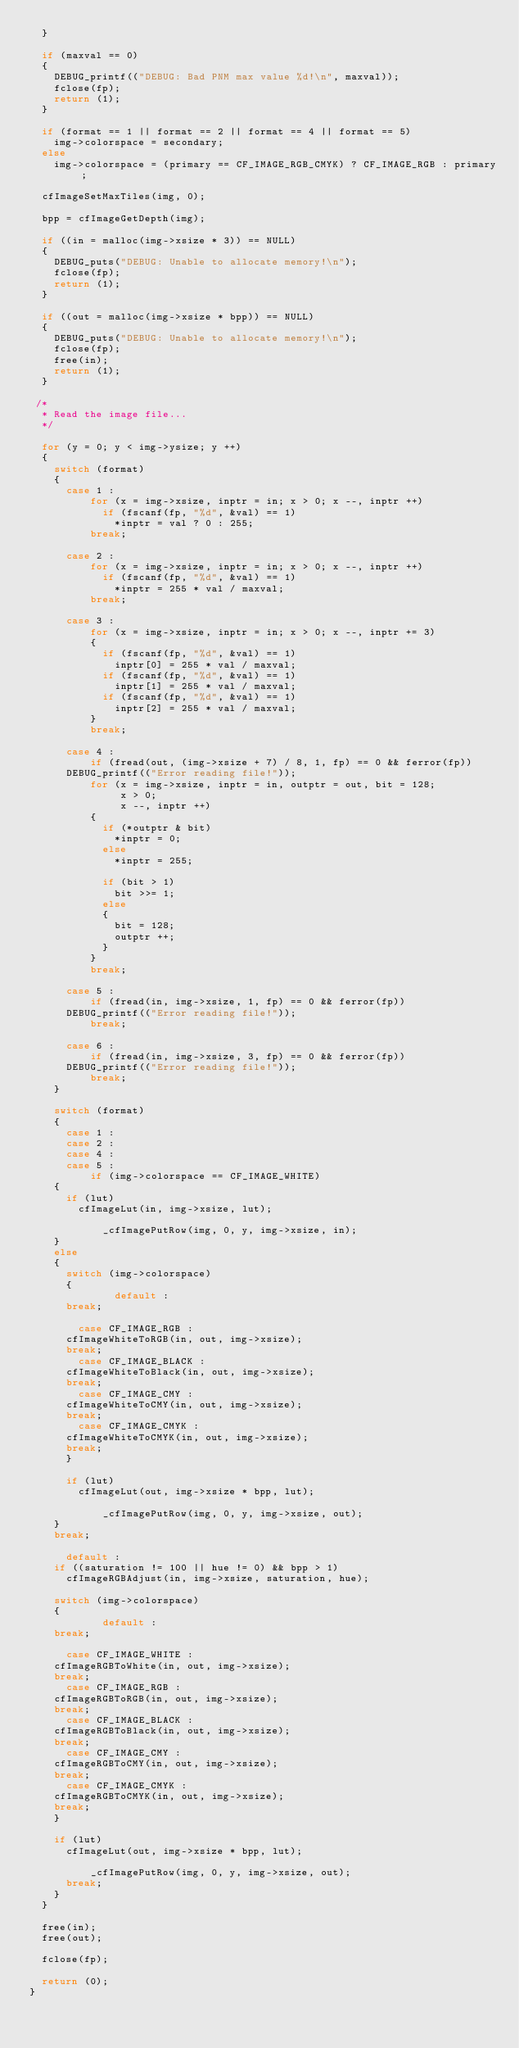Convert code to text. <code><loc_0><loc_0><loc_500><loc_500><_C_>  }

  if (maxval == 0)
  {
    DEBUG_printf(("DEBUG: Bad PNM max value %d!\n", maxval));
    fclose(fp);
    return (1);
  }

  if (format == 1 || format == 2 || format == 4 || format == 5)
    img->colorspace = secondary;
  else
    img->colorspace = (primary == CF_IMAGE_RGB_CMYK) ? CF_IMAGE_RGB : primary;

  cfImageSetMaxTiles(img, 0);

  bpp = cfImageGetDepth(img);

  if ((in = malloc(img->xsize * 3)) == NULL)
  {
    DEBUG_puts("DEBUG: Unable to allocate memory!\n");
    fclose(fp);
    return (1);
  }

  if ((out = malloc(img->xsize * bpp)) == NULL)
  {
    DEBUG_puts("DEBUG: Unable to allocate memory!\n");
    fclose(fp);
    free(in);
    return (1);
  }

 /*
  * Read the image file...
  */

  for (y = 0; y < img->ysize; y ++)
  {
    switch (format)
    {
      case 1 :
          for (x = img->xsize, inptr = in; x > 0; x --, inptr ++)
            if (fscanf(fp, "%d", &val) == 1)
              *inptr = val ? 0 : 255;
          break;

      case 2 :
          for (x = img->xsize, inptr = in; x > 0; x --, inptr ++)
            if (fscanf(fp, "%d", &val) == 1)
              *inptr = 255 * val / maxval;
          break;

      case 3 :
          for (x = img->xsize, inptr = in; x > 0; x --, inptr += 3)
          {
            if (fscanf(fp, "%d", &val) == 1)
              inptr[0] = 255 * val / maxval;
            if (fscanf(fp, "%d", &val) == 1)
              inptr[1] = 255 * val / maxval;
            if (fscanf(fp, "%d", &val) == 1)
              inptr[2] = 255 * val / maxval;
          }
          break;

      case 4 :
          if (fread(out, (img->xsize + 7) / 8, 1, fp) == 0 && ferror(fp))
	    DEBUG_printf(("Error reading file!"));
          for (x = img->xsize, inptr = in, outptr = out, bit = 128;
               x > 0;
               x --, inptr ++)
          {
            if (*outptr & bit)
              *inptr = 0;
            else
              *inptr = 255;

            if (bit > 1)
              bit >>= 1;
            else
            {
              bit = 128;
              outptr ++;
            }
          }
          break;

      case 5 :
          if (fread(in, img->xsize, 1, fp) == 0 && ferror(fp))
	    DEBUG_printf(("Error reading file!"));
          break;

      case 6 :
          if (fread(in, img->xsize, 3, fp) == 0 && ferror(fp))
	    DEBUG_printf(("Error reading file!"));
          break;
    }

    switch (format)
    {
      case 1 :
      case 2 :
      case 4 :
      case 5 :
          if (img->colorspace == CF_IMAGE_WHITE)
	  {
	    if (lut)
	      cfImageLut(in, img->xsize, lut);

            _cfImagePutRow(img, 0, y, img->xsize, in);
	  }
	  else
	  {
	    switch (img->colorspace)
	    {
              default :
		  break;

	      case CF_IMAGE_RGB :
		  cfImageWhiteToRGB(in, out, img->xsize);
		  break;
	      case CF_IMAGE_BLACK :
		  cfImageWhiteToBlack(in, out, img->xsize);
		  break;
	      case CF_IMAGE_CMY :
		  cfImageWhiteToCMY(in, out, img->xsize);
		  break;
	      case CF_IMAGE_CMYK :
		  cfImageWhiteToCMYK(in, out, img->xsize);
		  break;
	    }

	    if (lut)
	      cfImageLut(out, img->xsize * bpp, lut);

            _cfImagePutRow(img, 0, y, img->xsize, out);
	  }
	  break;

      default :
	  if ((saturation != 100 || hue != 0) && bpp > 1)
	    cfImageRGBAdjust(in, img->xsize, saturation, hue);

	  switch (img->colorspace)
	  {
            default :
		break;

	    case CF_IMAGE_WHITE :
		cfImageRGBToWhite(in, out, img->xsize);
		break;
	    case CF_IMAGE_RGB :
		cfImageRGBToRGB(in, out, img->xsize);
		break;
	    case CF_IMAGE_BLACK :
		cfImageRGBToBlack(in, out, img->xsize);
		break;
	    case CF_IMAGE_CMY :
		cfImageRGBToCMY(in, out, img->xsize);
		break;
	    case CF_IMAGE_CMYK :
		cfImageRGBToCMYK(in, out, img->xsize);
		break;
	  }

	  if (lut)
	    cfImageLut(out, img->xsize * bpp, lut);

          _cfImagePutRow(img, 0, y, img->xsize, out);
  	  break;
    }
  }

  free(in);
  free(out);

  fclose(fp);

  return (0);
}

</code> 